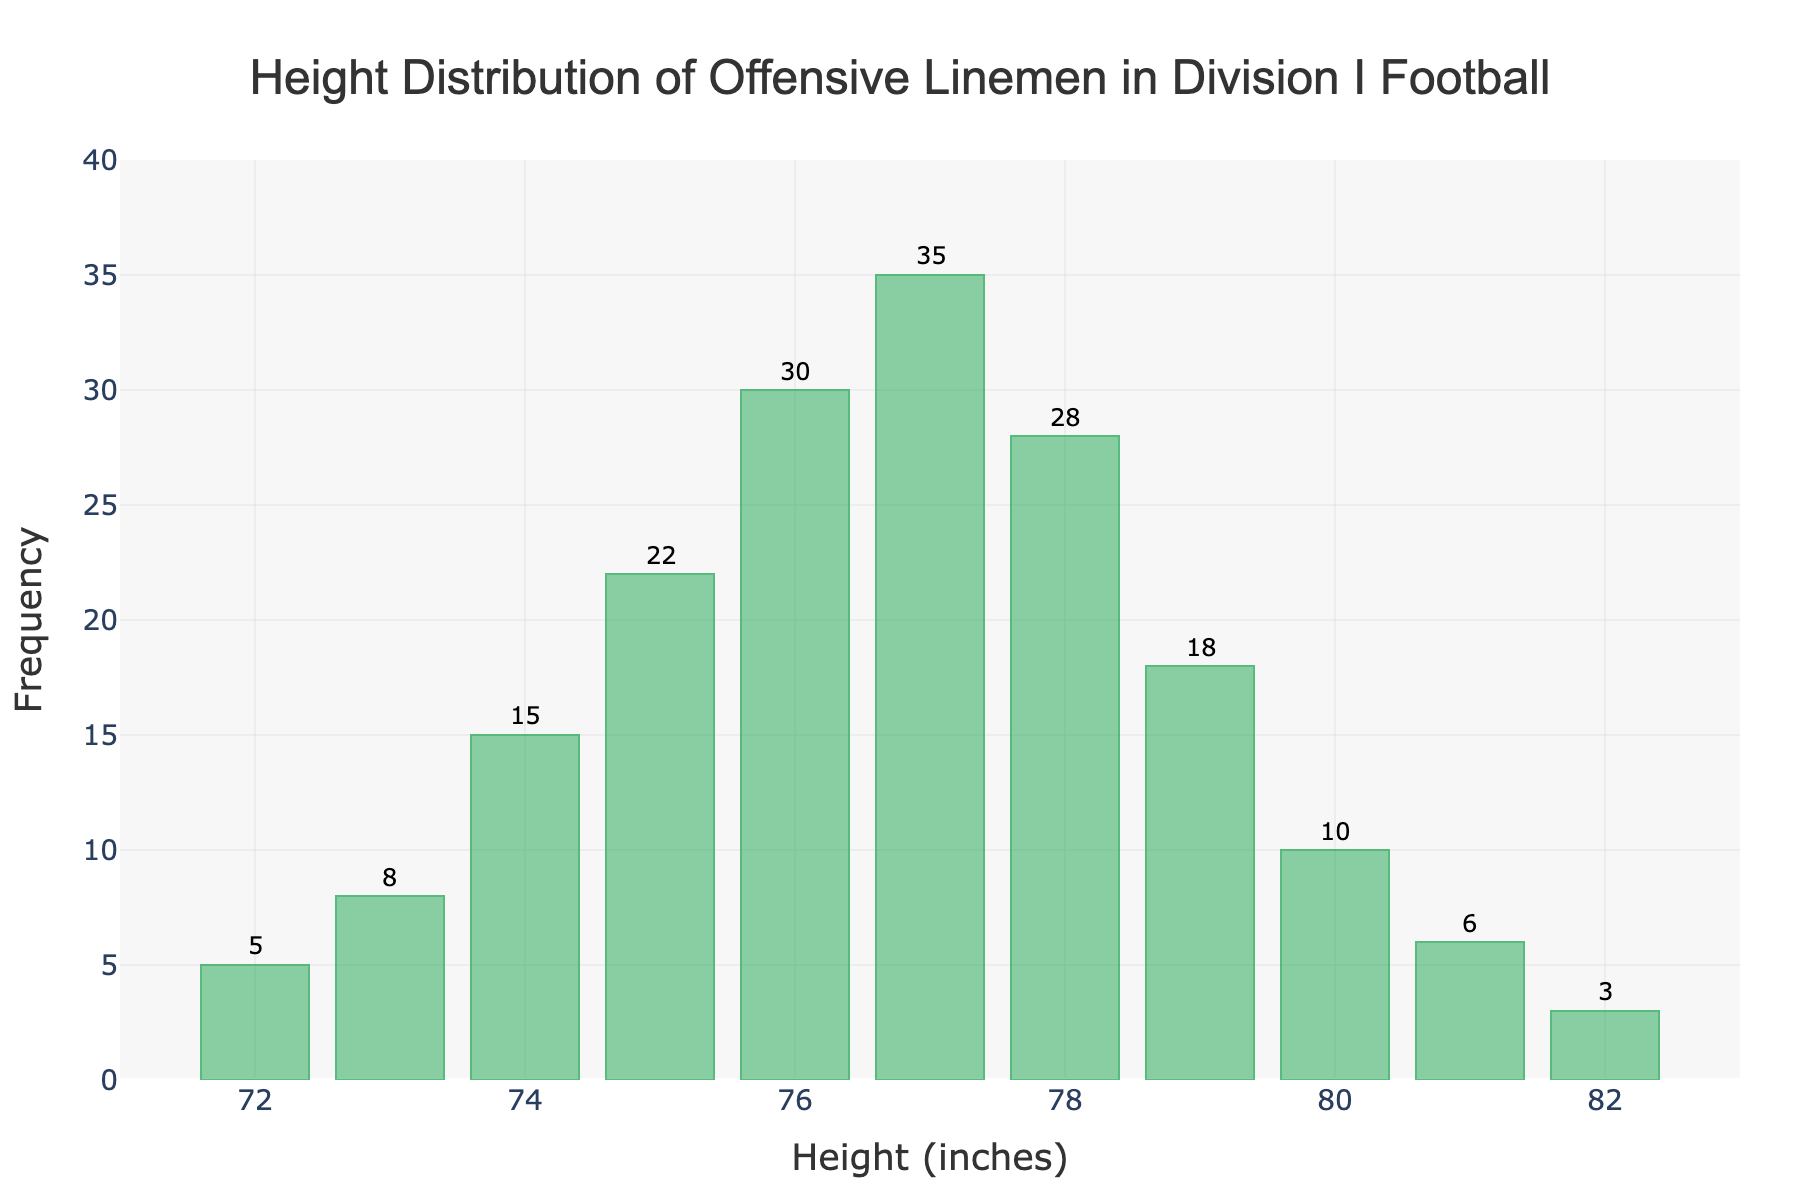What's the title of the chart? The title of the chart is displayed at the top and reads 'Height Distribution of Offensive Linemen in Division I Football'.
Answer: 'Height Distribution of Offensive Linemen in Division I Football' How many offensive linemen are 76 inches tall? To find the number of offensive linemen who are 76 inches tall, look at the bar corresponding to 76 inches on the x-axis and check the height of the bar, which is 30.
Answer: 30 What is the height with the highest frequency of offensive linemen? The height with the highest frequency will be the tallest bar in the histogram. The bar for 77 inches is the tallest with a frequency of 35.
Answer: 77 inches What is the frequency difference between the heights of 77 inches and 78 inches? To find the frequency difference, subtract the frequency of 78 inches (28) from the frequency of 77 inches (35): 35 - 28.
Answer: 7 What is the total number of offensive linemen represented in the histogram? To find the total number of offensive linemen, sum all the frequencies: 5 + 8 + 15 + 22 + 30 + 35 + 28 + 18 + 10 + 6 + 3.
Answer: 180 What is the average height of the offensive linemen? To find the average height, multiply each height by its frequency, sum those products, and then divide by the total frequency. (72*5 + 73*8 + 74*15 + 75*22 + 76*30 + 77*35 + 78*28 + 79*18 + 80*10 + 81*6 + 82*3) / 180.
Answer: 76.5 inches Which height has the smallest frequency and what is that frequency? The smallest frequency can be found by identifying the shortest bar, which is for the height 82 inches with a frequency of 3.
Answer: 82 inches, 3 What percentage of offensive linemen are 77 inches tall? To find the percentage, divide the frequency of 77 inches (35) by the total number of linemen (180), and then multiply by 100: (35 / 180) * 100.
Answer: 19.44% Are there more offensive linemen that are 75 inches tall or 78 inches tall? Compare the frequencies of the two heights. 75 inches has 22 linemen and 78 inches has 28 linemen.
Answer: 78 inches What is the range of heights in the histogram? The range of heights is calculated by subtracting the smallest height (72 inches) from the largest height (82 inches): 82 - 72.
Answer: 10 inches 